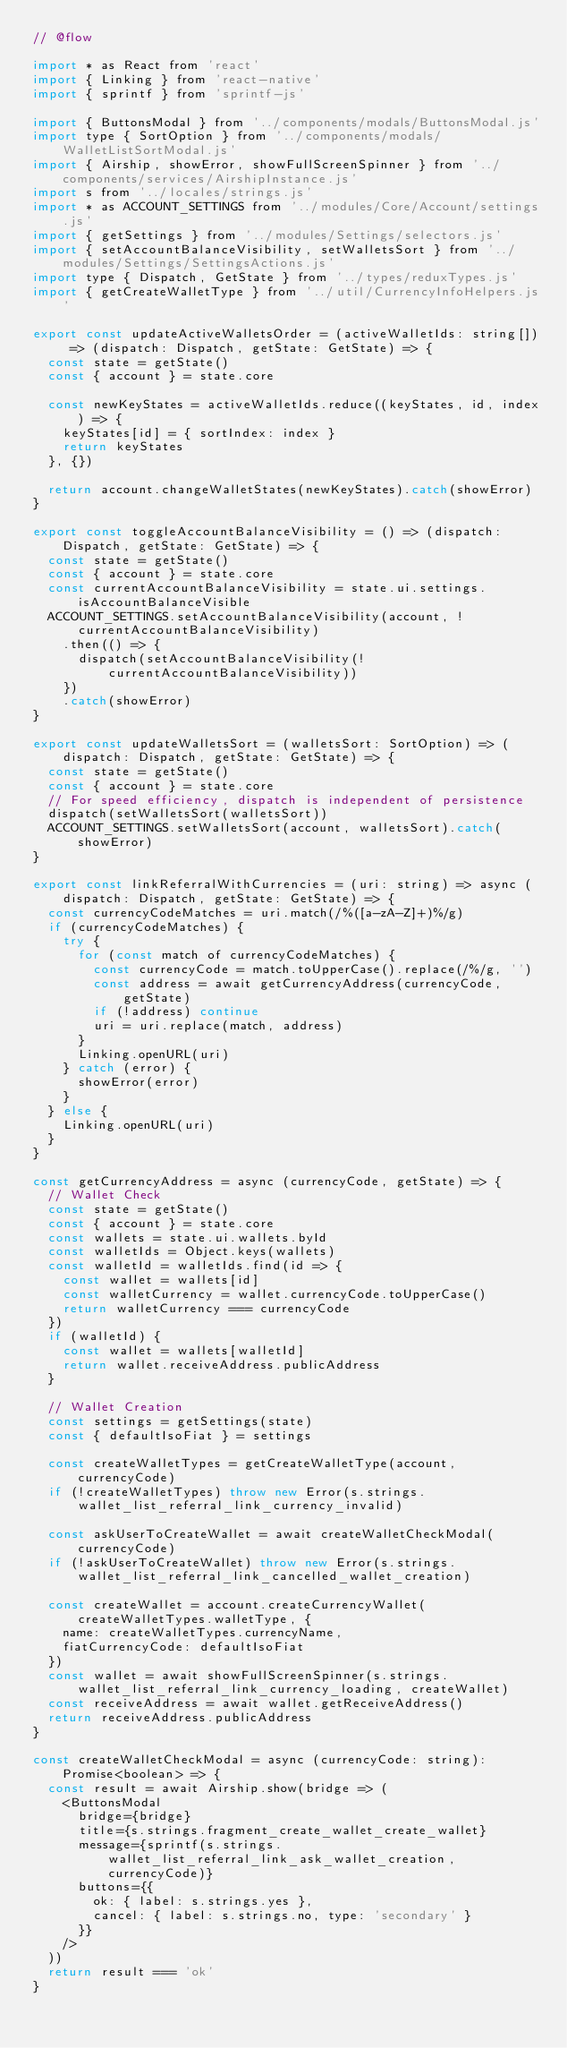<code> <loc_0><loc_0><loc_500><loc_500><_JavaScript_>// @flow

import * as React from 'react'
import { Linking } from 'react-native'
import { sprintf } from 'sprintf-js'

import { ButtonsModal } from '../components/modals/ButtonsModal.js'
import type { SortOption } from '../components/modals/WalletListSortModal.js'
import { Airship, showError, showFullScreenSpinner } from '../components/services/AirshipInstance.js'
import s from '../locales/strings.js'
import * as ACCOUNT_SETTINGS from '../modules/Core/Account/settings.js'
import { getSettings } from '../modules/Settings/selectors.js'
import { setAccountBalanceVisibility, setWalletsSort } from '../modules/Settings/SettingsActions.js'
import type { Dispatch, GetState } from '../types/reduxTypes.js'
import { getCreateWalletType } from '../util/CurrencyInfoHelpers.js'

export const updateActiveWalletsOrder = (activeWalletIds: string[]) => (dispatch: Dispatch, getState: GetState) => {
  const state = getState()
  const { account } = state.core

  const newKeyStates = activeWalletIds.reduce((keyStates, id, index) => {
    keyStates[id] = { sortIndex: index }
    return keyStates
  }, {})

  return account.changeWalletStates(newKeyStates).catch(showError)
}

export const toggleAccountBalanceVisibility = () => (dispatch: Dispatch, getState: GetState) => {
  const state = getState()
  const { account } = state.core
  const currentAccountBalanceVisibility = state.ui.settings.isAccountBalanceVisible
  ACCOUNT_SETTINGS.setAccountBalanceVisibility(account, !currentAccountBalanceVisibility)
    .then(() => {
      dispatch(setAccountBalanceVisibility(!currentAccountBalanceVisibility))
    })
    .catch(showError)
}

export const updateWalletsSort = (walletsSort: SortOption) => (dispatch: Dispatch, getState: GetState) => {
  const state = getState()
  const { account } = state.core
  // For speed efficiency, dispatch is independent of persistence
  dispatch(setWalletsSort(walletsSort))
  ACCOUNT_SETTINGS.setWalletsSort(account, walletsSort).catch(showError)
}

export const linkReferralWithCurrencies = (uri: string) => async (dispatch: Dispatch, getState: GetState) => {
  const currencyCodeMatches = uri.match(/%([a-zA-Z]+)%/g)
  if (currencyCodeMatches) {
    try {
      for (const match of currencyCodeMatches) {
        const currencyCode = match.toUpperCase().replace(/%/g, '')
        const address = await getCurrencyAddress(currencyCode, getState)
        if (!address) continue
        uri = uri.replace(match, address)
      }
      Linking.openURL(uri)
    } catch (error) {
      showError(error)
    }
  } else {
    Linking.openURL(uri)
  }
}

const getCurrencyAddress = async (currencyCode, getState) => {
  // Wallet Check
  const state = getState()
  const { account } = state.core
  const wallets = state.ui.wallets.byId
  const walletIds = Object.keys(wallets)
  const walletId = walletIds.find(id => {
    const wallet = wallets[id]
    const walletCurrency = wallet.currencyCode.toUpperCase()
    return walletCurrency === currencyCode
  })
  if (walletId) {
    const wallet = wallets[walletId]
    return wallet.receiveAddress.publicAddress
  }

  // Wallet Creation
  const settings = getSettings(state)
  const { defaultIsoFiat } = settings

  const createWalletTypes = getCreateWalletType(account, currencyCode)
  if (!createWalletTypes) throw new Error(s.strings.wallet_list_referral_link_currency_invalid)

  const askUserToCreateWallet = await createWalletCheckModal(currencyCode)
  if (!askUserToCreateWallet) throw new Error(s.strings.wallet_list_referral_link_cancelled_wallet_creation)

  const createWallet = account.createCurrencyWallet(createWalletTypes.walletType, {
    name: createWalletTypes.currencyName,
    fiatCurrencyCode: defaultIsoFiat
  })
  const wallet = await showFullScreenSpinner(s.strings.wallet_list_referral_link_currency_loading, createWallet)
  const receiveAddress = await wallet.getReceiveAddress()
  return receiveAddress.publicAddress
}

const createWalletCheckModal = async (currencyCode: string): Promise<boolean> => {
  const result = await Airship.show(bridge => (
    <ButtonsModal
      bridge={bridge}
      title={s.strings.fragment_create_wallet_create_wallet}
      message={sprintf(s.strings.wallet_list_referral_link_ask_wallet_creation, currencyCode)}
      buttons={{
        ok: { label: s.strings.yes },
        cancel: { label: s.strings.no, type: 'secondary' }
      }}
    />
  ))
  return result === 'ok'
}
</code> 